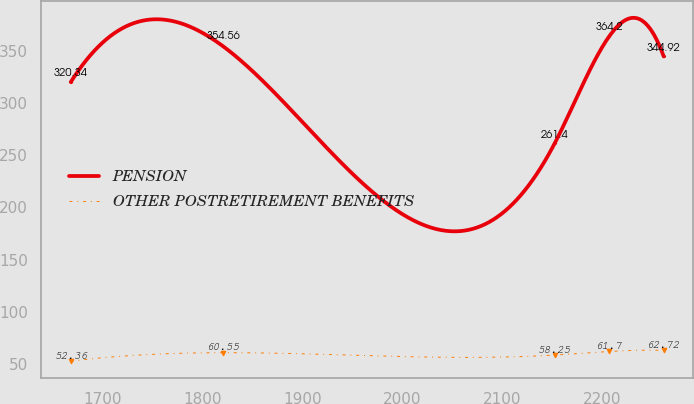Convert chart to OTSL. <chart><loc_0><loc_0><loc_500><loc_500><line_chart><ecel><fcel>PENSION<fcel>OTHER POSTRETIREMENT BENEFITS<nl><fcel>1668.32<fcel>320.34<fcel>52.36<nl><fcel>1820.95<fcel>354.56<fcel>60.55<nl><fcel>2152.55<fcel>261.4<fcel>58.25<nl><fcel>2207.14<fcel>364.2<fcel>61.7<nl><fcel>2261.73<fcel>344.92<fcel>62.72<nl></chart> 